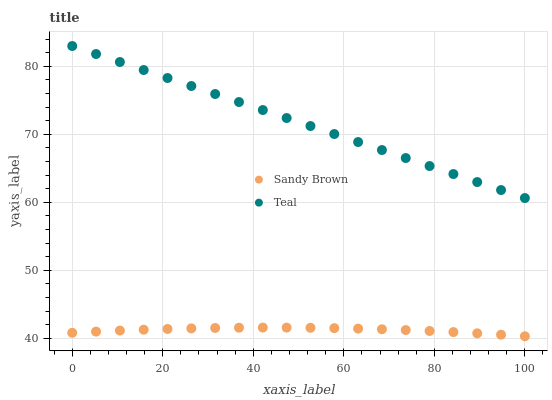Does Sandy Brown have the minimum area under the curve?
Answer yes or no. Yes. Does Teal have the maximum area under the curve?
Answer yes or no. Yes. Does Teal have the minimum area under the curve?
Answer yes or no. No. Is Teal the smoothest?
Answer yes or no. Yes. Is Sandy Brown the roughest?
Answer yes or no. Yes. Is Teal the roughest?
Answer yes or no. No. Does Sandy Brown have the lowest value?
Answer yes or no. Yes. Does Teal have the lowest value?
Answer yes or no. No. Does Teal have the highest value?
Answer yes or no. Yes. Is Sandy Brown less than Teal?
Answer yes or no. Yes. Is Teal greater than Sandy Brown?
Answer yes or no. Yes. Does Sandy Brown intersect Teal?
Answer yes or no. No. 